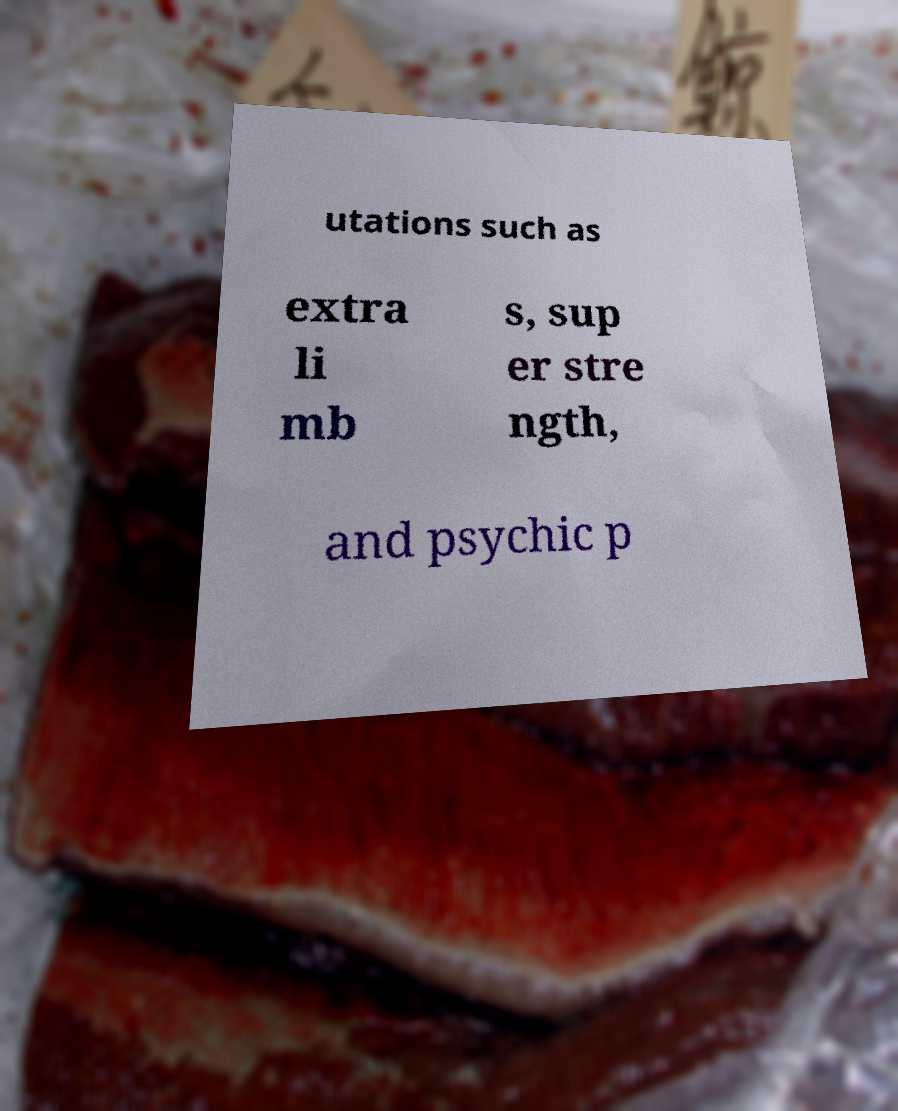Please identify and transcribe the text found in this image. utations such as extra li mb s, sup er stre ngth, and psychic p 